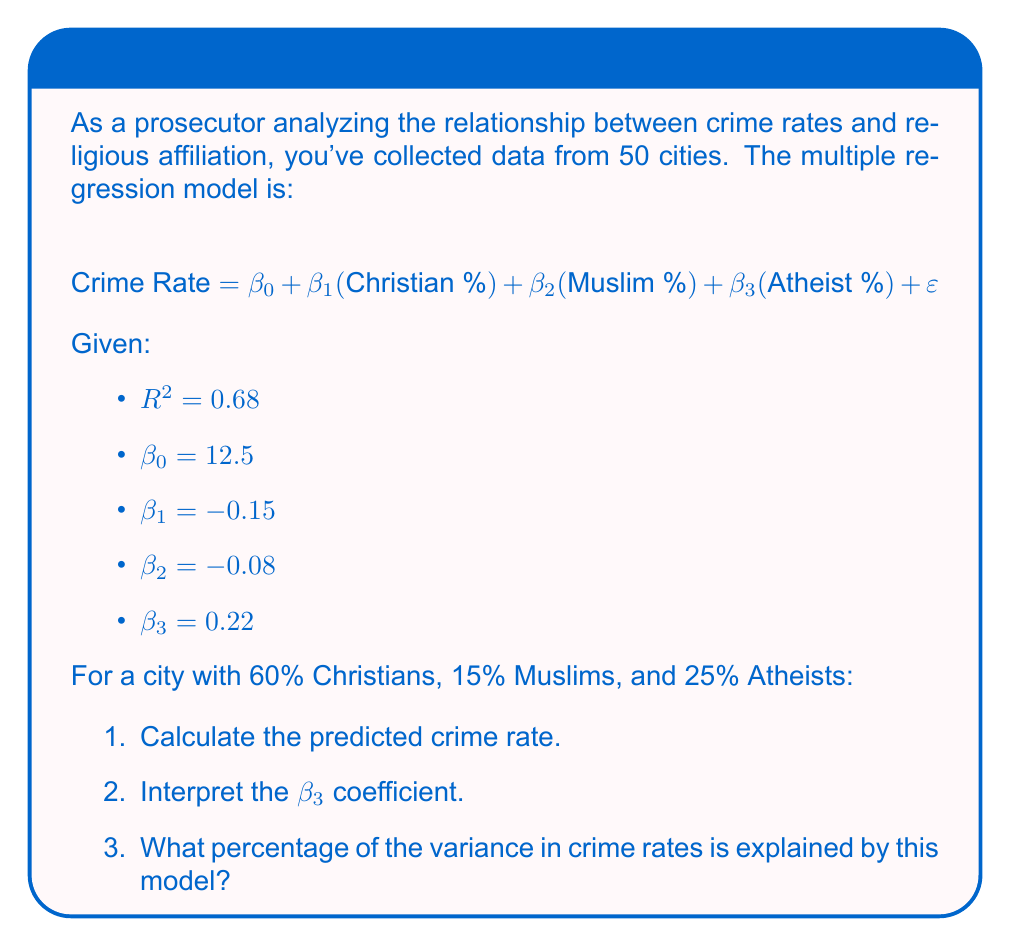Give your solution to this math problem. 1. To calculate the predicted crime rate, we substitute the given percentages into the regression equation:

   $$\text{Crime Rate} = 12.5 + (-0.15 \times 60) + (-0.08 \times 15) + (0.22 \times 25)$$
   $$= 12.5 - 9 - 1.2 + 5.5 = 7.8$$

2. The $\beta_3$ coefficient (0.22) represents the change in crime rate associated with a 1% increase in the Atheist population, holding other variables constant. A positive value indicates that as the Atheist percentage increases, the crime rate tends to increase.

3. The $R^2$ value of 0.68 indicates the proportion of variance in the crime rate explained by the model. To express this as a percentage:

   $$0.68 \times 100\% = 68\%$$

   This means that 68% of the variance in crime rates is explained by the religious affiliation variables in this model.
Answer: 1. 7.8
2. For each 1% increase in Atheist population, crime rate increases by 0.22 units, ceteris paribus.
3. 68% 